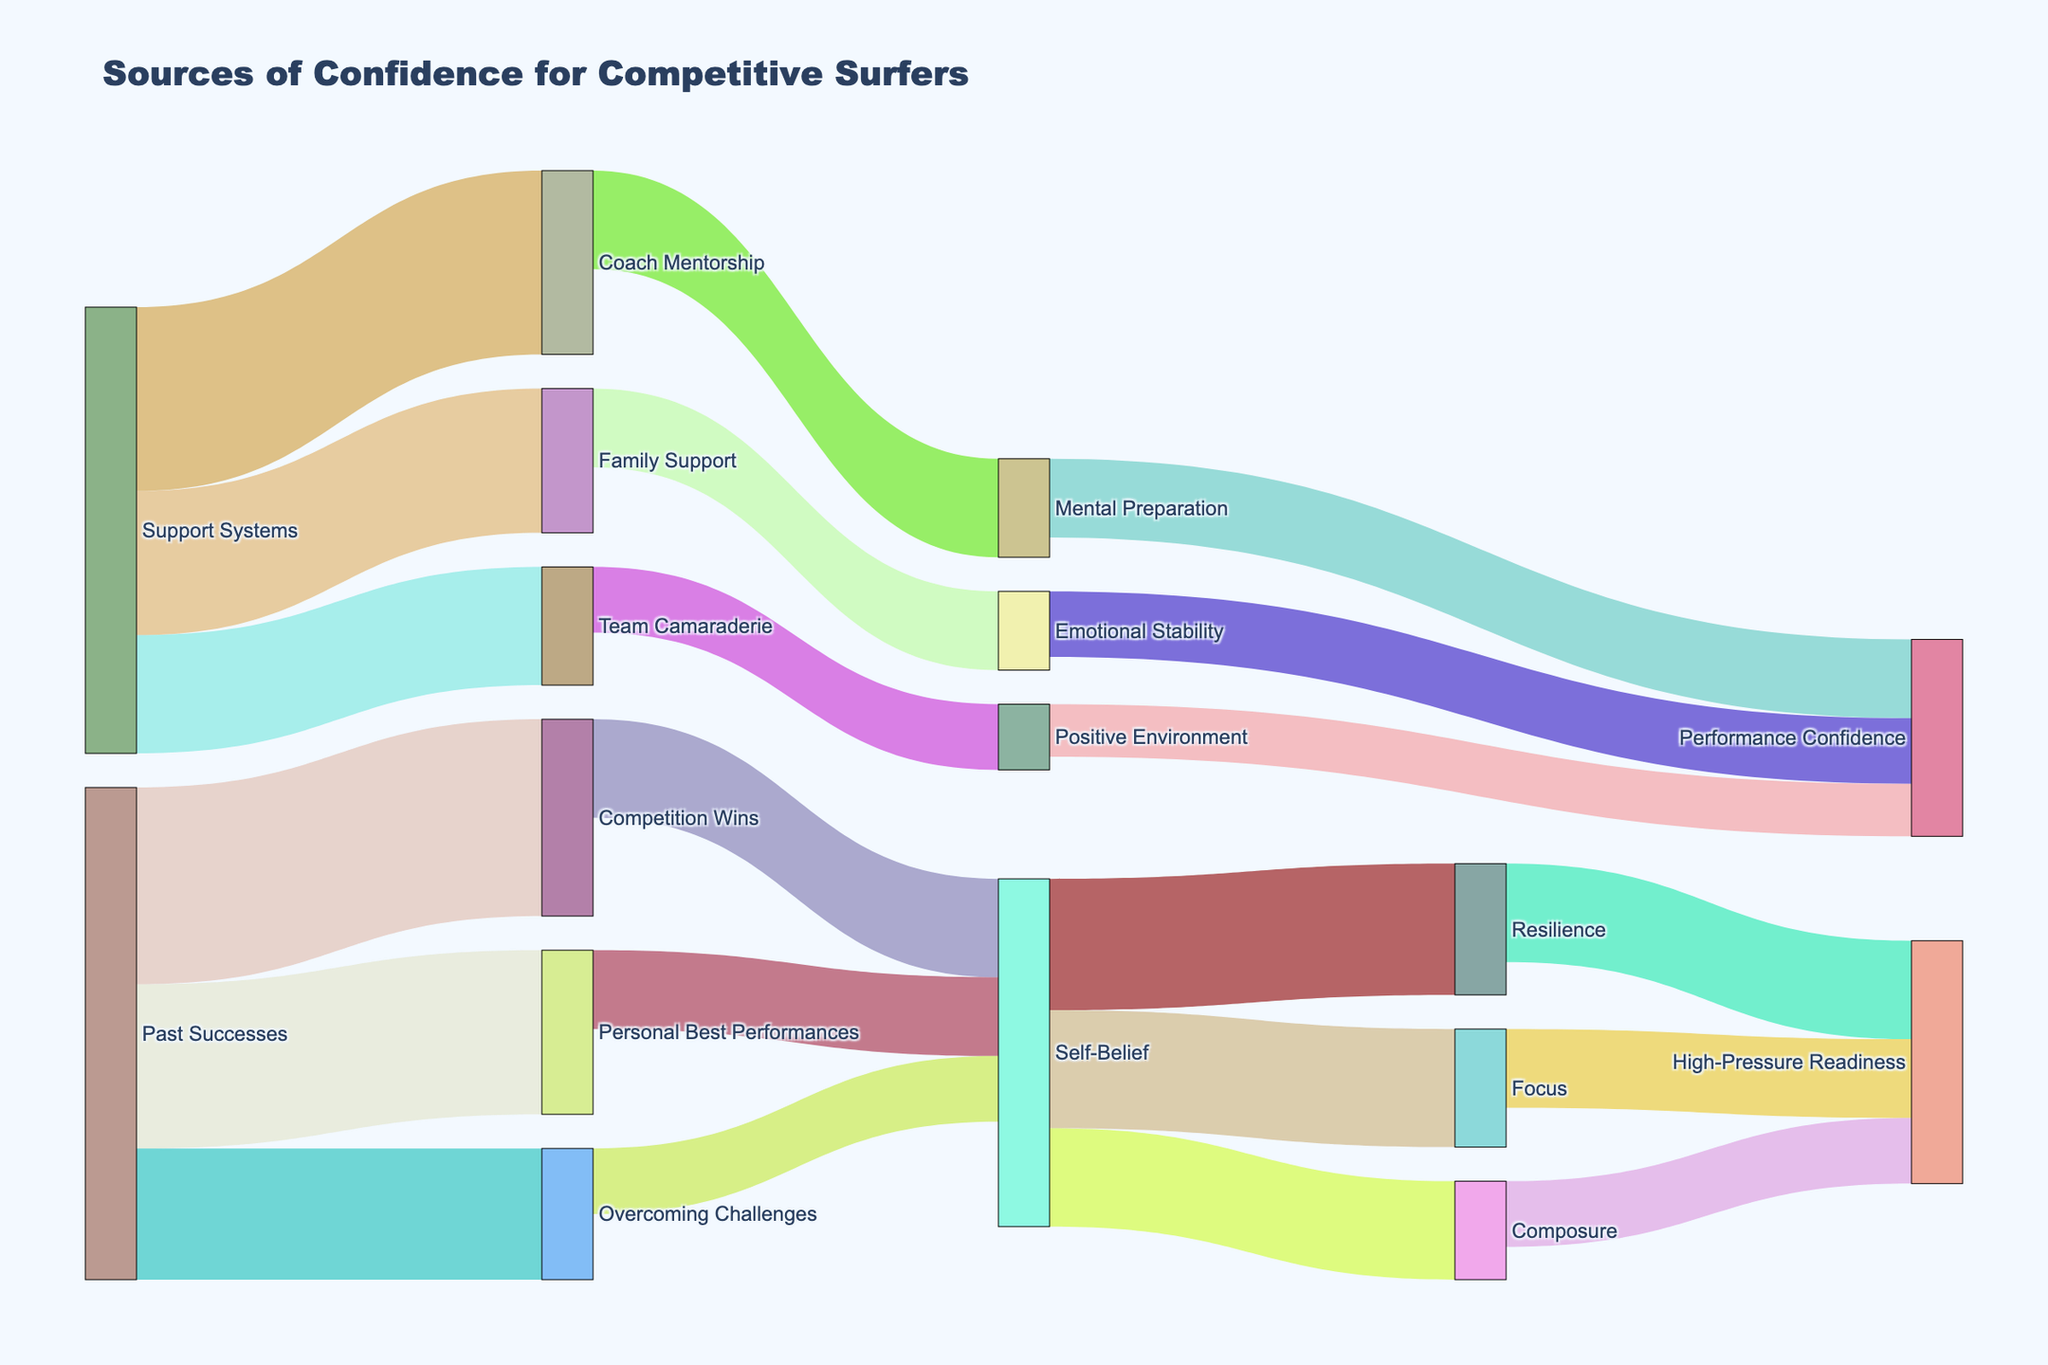What is the main source of "Self-Belief"? The "Self-Belief" node receives flows from "Competition Wins" (15), "Personal Best Performances" (12), and "Overcoming Challenges" (10). The largest flow value is from "Competition Wins" with a value of 15.
Answer: Competition Wins Which source has the highest value leading to "Performance Confidence"? "Performance Confidence" receives flows from "Mental Preparation" (12), "Emotional Stability" (10), and "Positive Environment" (8). The highest flow value is from "Mental Preparation" with a value of 12.
Answer: Mental Preparation How many nodes are there in total? The total number of unique nodes in the Sankey Diagram can be counted from the list of sources and targets. There are 17 unique nodes.
Answer: 17 What's the combined value flowing from "Support Systems" to its targets? "Support Systems" has flows leading to "Coach Mentorship" (28), "Family Support" (22), and "Team Camaraderie" (18). The combined value is 28 + 22 + 18 = 68.
Answer: 68 Which target has the smallest value flowing to it? Identify all target nodes and their incoming values. The smallest value flows to "Positive Environment" with a value of 10.
Answer: Positive Environment How does the value from "Overcoming Challenges" contribute to "High-Pressure Readiness"? "Overcoming Challenges" flows to "Self-Belief" (10), which then flows to "Resilience," "Focus," and "Composure." Specifically, for "High-Pressure Readiness," "Resilience," "Focus," and "Composure" further flow into it. First, "Overcoming Challenges" to "Self-Belief" is 10. Then "Self-Belief" to "Resilience" is part of that 10; however, evaluating full transfer path accurately is complex, but initial key node is "Self-Belief."
Answer: Self-Belief Which path from "Past Successes" ends up impacting "Performance Confidence" specifically? From "Past Successes," the flow impacts "Self-Belief" directly and then spreads across. Specifically, looking for "Performance Confidence:" "Past Successes" to "Competition Wins" -> "Self-Belief" -> "Resilience" -> "High-Pressure Readiness". "Past Successes" also contributes directly to "Overcoming Challenges" -> "Self-Belief". Performance Confidence path includes linkage with Self-Belief shifting -> "Resilience focus."
Answer: Via Self-Belief 